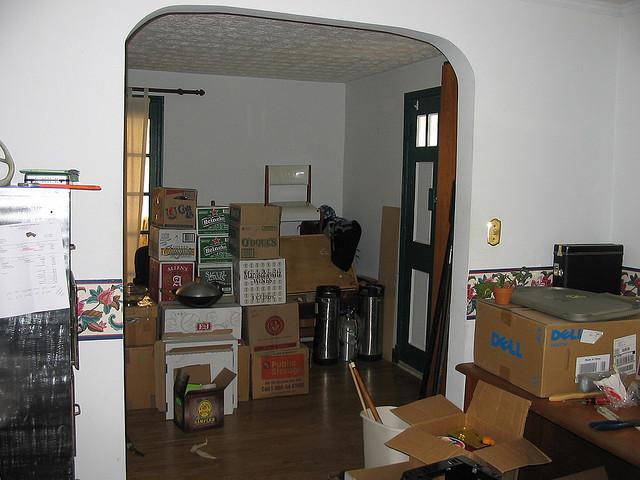Was this picture taken inside the train?
Write a very short answer. No. Is there where I go if I need to pee?
Short answer required. No. What is stacked up?
Answer briefly. Boxes. What number of luggage is on the table?
Answer briefly. 0. Is this a basement?
Short answer required. No. Are there any jackets hanging?
Answer briefly. No. What is this room?
Answer briefly. Dining room. What color is the wall?
Quick response, please. White. What type of flooring is in this house?
Be succinct. Wood. 